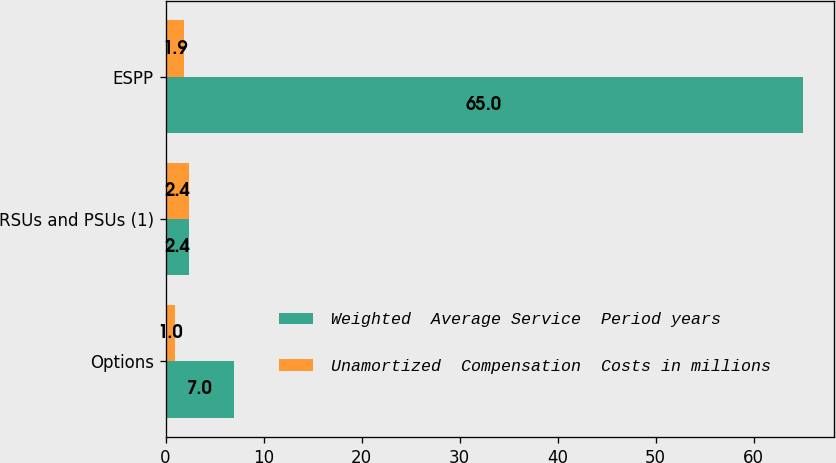Convert chart. <chart><loc_0><loc_0><loc_500><loc_500><stacked_bar_chart><ecel><fcel>Options<fcel>RSUs and PSUs (1)<fcel>ESPP<nl><fcel>Weighted  Average Service  Period years<fcel>7<fcel>2.4<fcel>65<nl><fcel>Unamortized  Compensation  Costs in millions<fcel>1<fcel>2.4<fcel>1.9<nl></chart> 